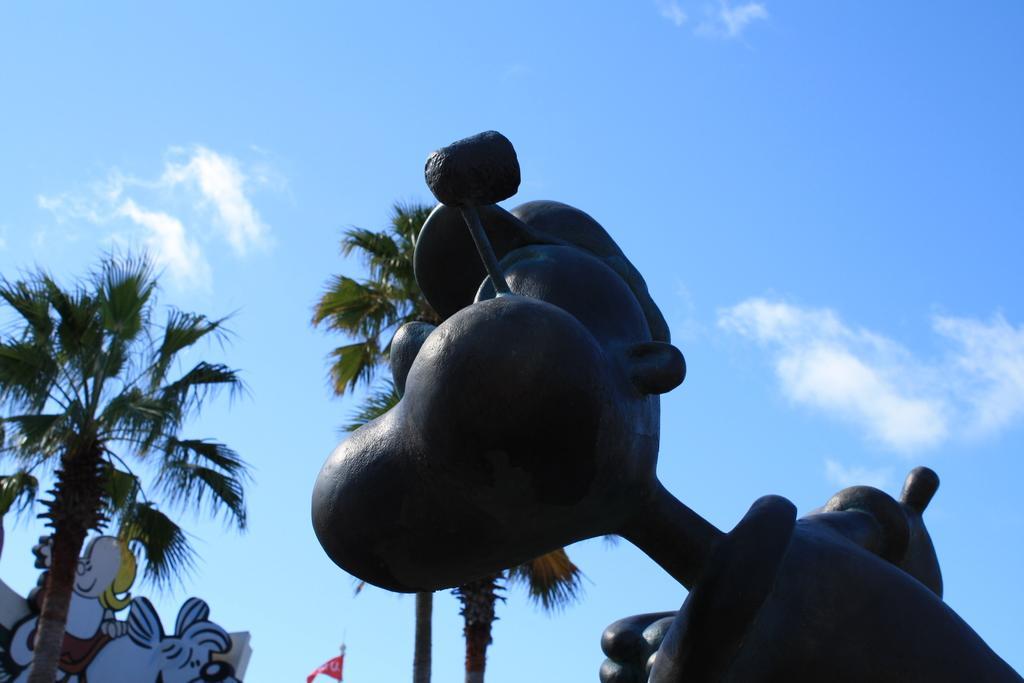In one or two sentences, can you explain what this image depicts? In this picture we can see blue sky, coconut trees and a bronze statue. 